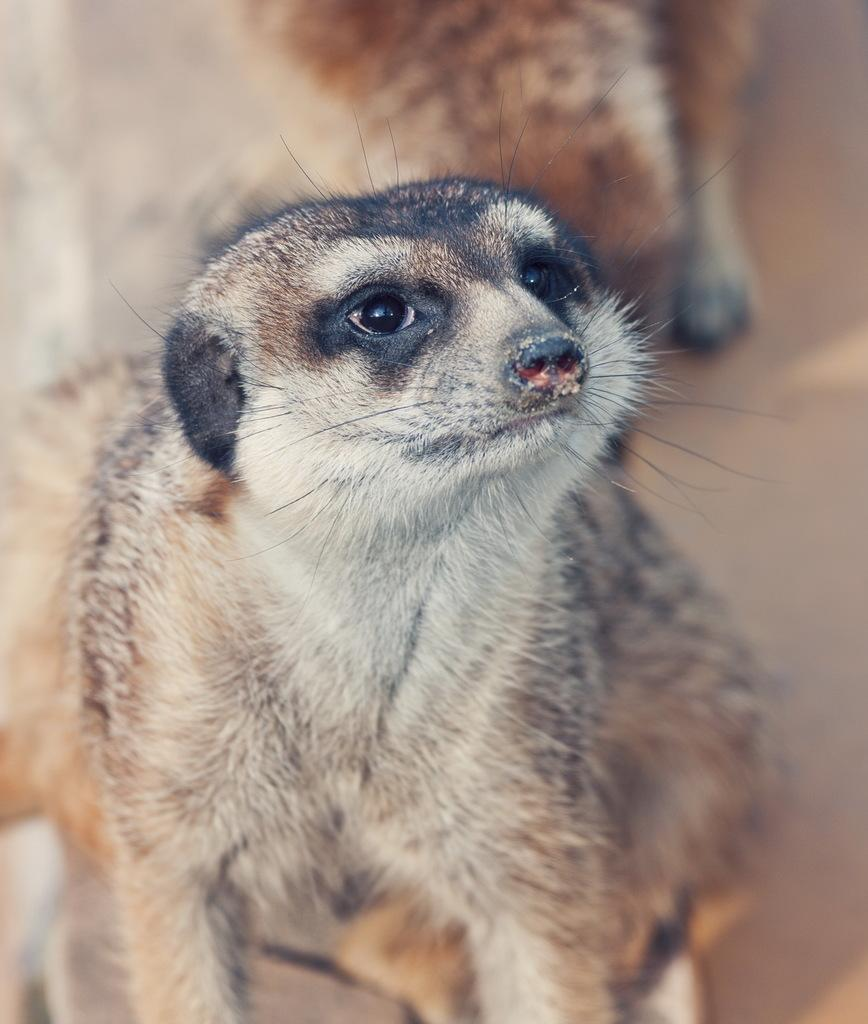What animal is the main subject of the image? There is a meerkat in the image. Can you describe the background of the image? The background of the image is blurred. What type of mint is growing in the image? There is no mint present in the image; it features a meerkat with a blurred background. How many feathers can be seen on the meerkat's tail in the image? Meerkats do not have feathers or tails, so this question cannot be answered based on the image. 